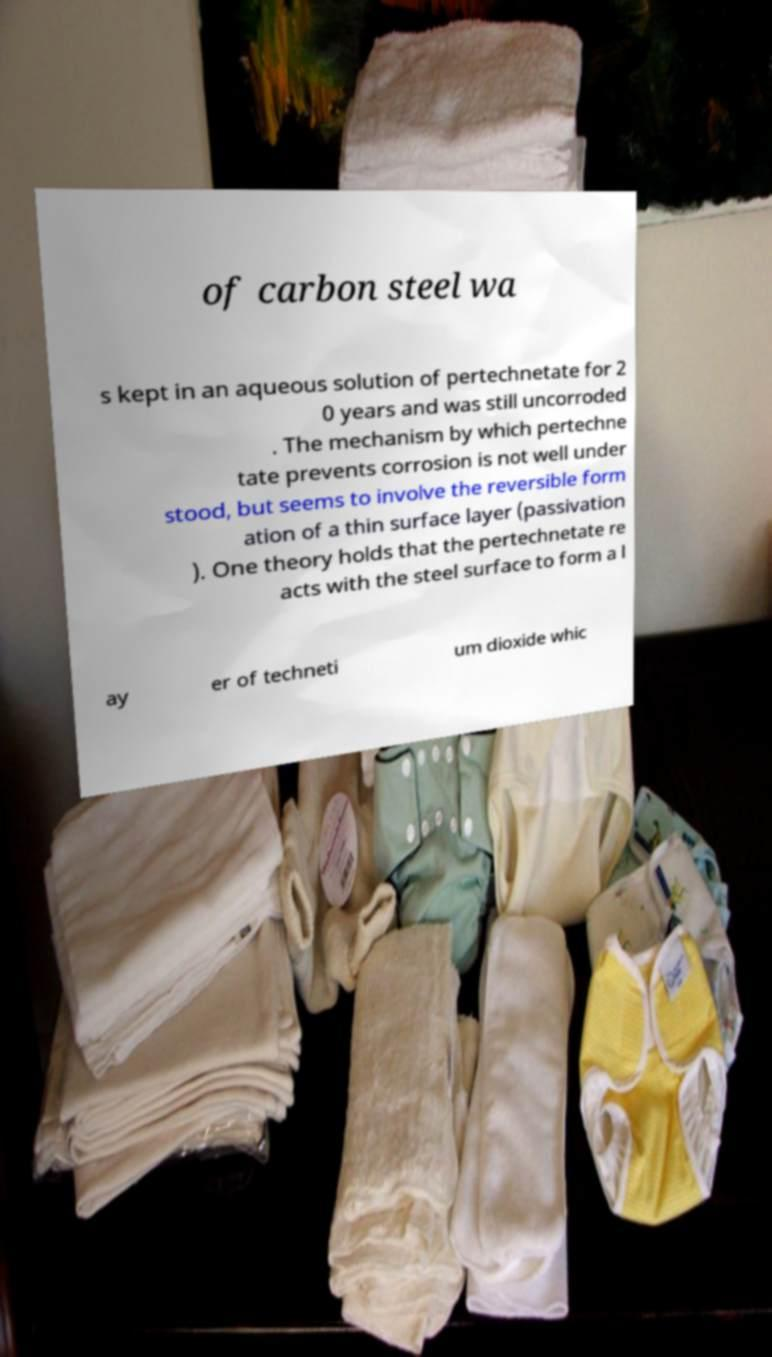For documentation purposes, I need the text within this image transcribed. Could you provide that? of carbon steel wa s kept in an aqueous solution of pertechnetate for 2 0 years and was still uncorroded . The mechanism by which pertechne tate prevents corrosion is not well under stood, but seems to involve the reversible form ation of a thin surface layer (passivation ). One theory holds that the pertechnetate re acts with the steel surface to form a l ay er of techneti um dioxide whic 